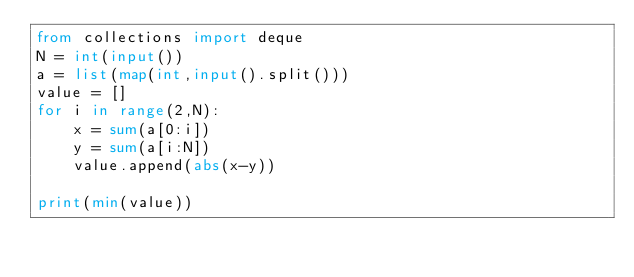Convert code to text. <code><loc_0><loc_0><loc_500><loc_500><_Python_>from collections import deque
N = int(input())
a = list(map(int,input().split()))
value = []
for i in range(2,N):
    x = sum(a[0:i])
    y = sum(a[i:N])
    value.append(abs(x-y))

print(min(value))
</code> 